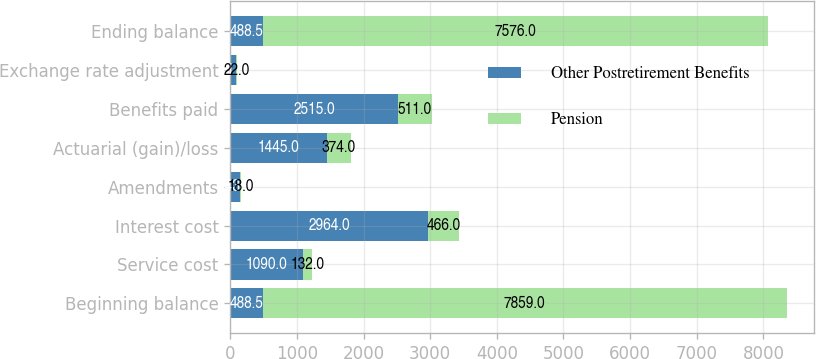Convert chart. <chart><loc_0><loc_0><loc_500><loc_500><stacked_bar_chart><ecel><fcel>Beginning balance<fcel>Service cost<fcel>Interest cost<fcel>Amendments<fcel>Actuarial (gain)/loss<fcel>Benefits paid<fcel>Exchange rate adjustment<fcel>Ending balance<nl><fcel>Other Postretirement Benefits<fcel>488.5<fcel>1090<fcel>2964<fcel>143<fcel>1445<fcel>2515<fcel>81<fcel>488.5<nl><fcel>Pension<fcel>7859<fcel>132<fcel>466<fcel>18<fcel>374<fcel>511<fcel>22<fcel>7576<nl></chart> 